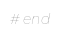Convert code to text. <code><loc_0><loc_0><loc_500><loc_500><_Ruby_># end
</code> 